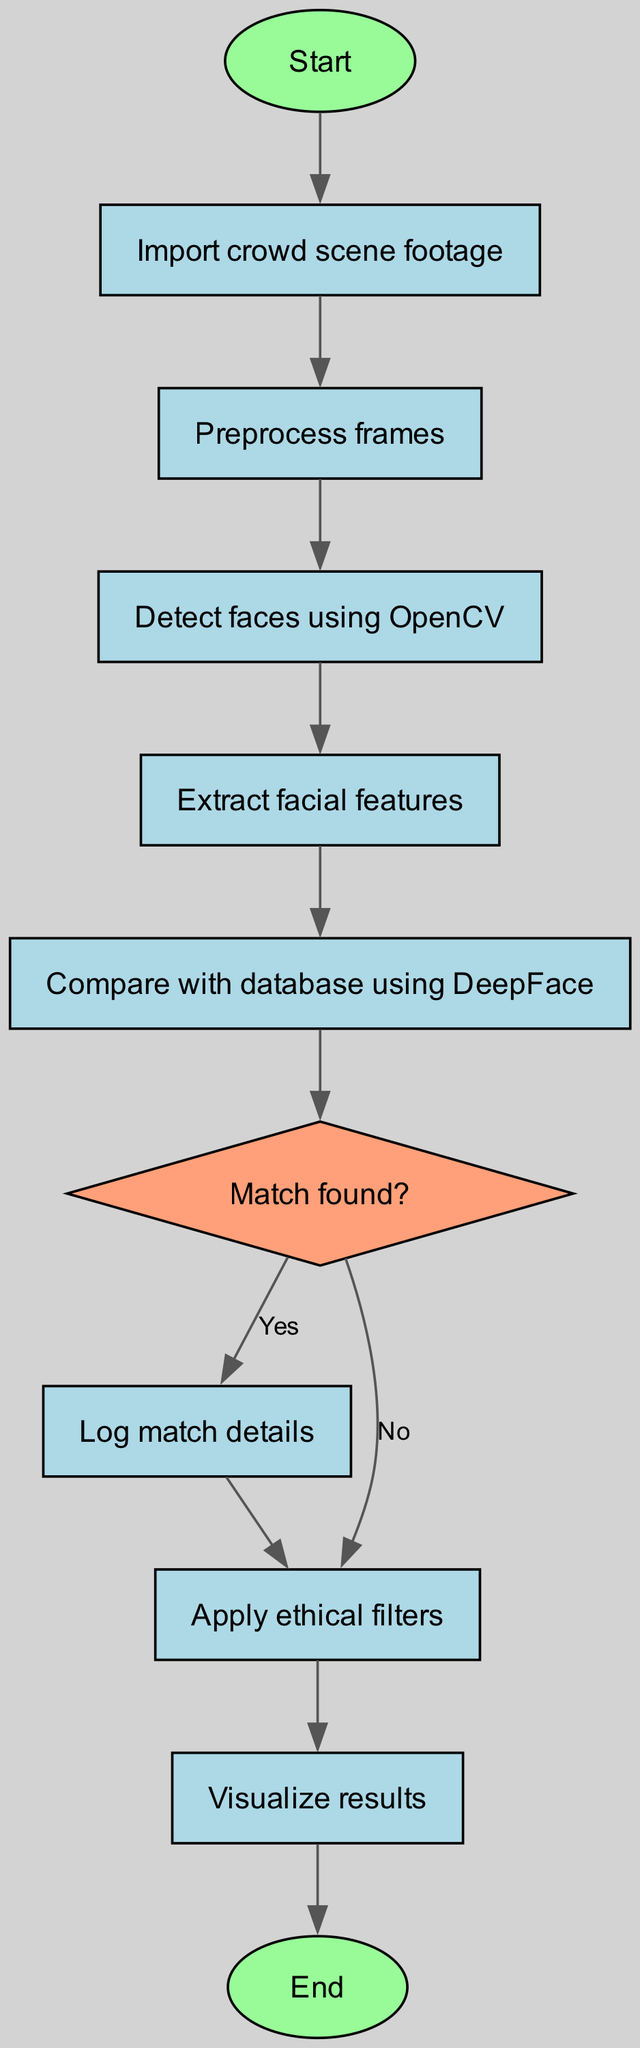What is the starting node of the flowchart? The flowchart begins at the node labeled "Start." This is indicated explicitly in the diagram as the first point of action.
Answer: Start How many nodes are in the flowchart? By counting the individual nodes listed in the data section, we can find that there are a total of ten nodes included in the flowchart.
Answer: Ten What action is performed after importing the crowd scene footage? Following the "Import crowd scene footage" node, the next action is "Preprocess frames." This shows the sequence of operations as defined in the diagram.
Answer: Preprocess frames What occurs if a match is found during the comparison? If a match is found, the flow proceeds to the "Log match details" node, indicating that relevant details will be recorded for the matched facial recognition.
Answer: Log match details If no match is found, which process follows? In the case where no match is found, the flow goes to the "Apply ethical filters" node, denoting a step regarding the ethical considerations of no identified faces.
Answer: Apply ethical filters Which node indicates a decision point in the flowchart? The node labeled "Match found?" is the decision point, as it determines the subsequent path based on whether a match is found or not.
Answer: Match found? What is the final action to visualize the results after applying ethical filters? After the ethical filters are applied, the next step in the flowchart is to "Visualize results," which indicates that the outcomes of the recognition process will be presented.
Answer: Visualize results How does the flow proceed if a match is successful? If a match is successful, the flow first directs to "Log match details" and then to "Apply ethical filters," thus capturing match data before applying any ethical considerations.
Answer: Log match details, Apply ethical filters What shape is used for the decision node in the flowchart? The decision node is represented by a diamond shape, distinguishing it from the other rectangular action nodes, which shows its dual pathway nature.
Answer: Diamond shape 